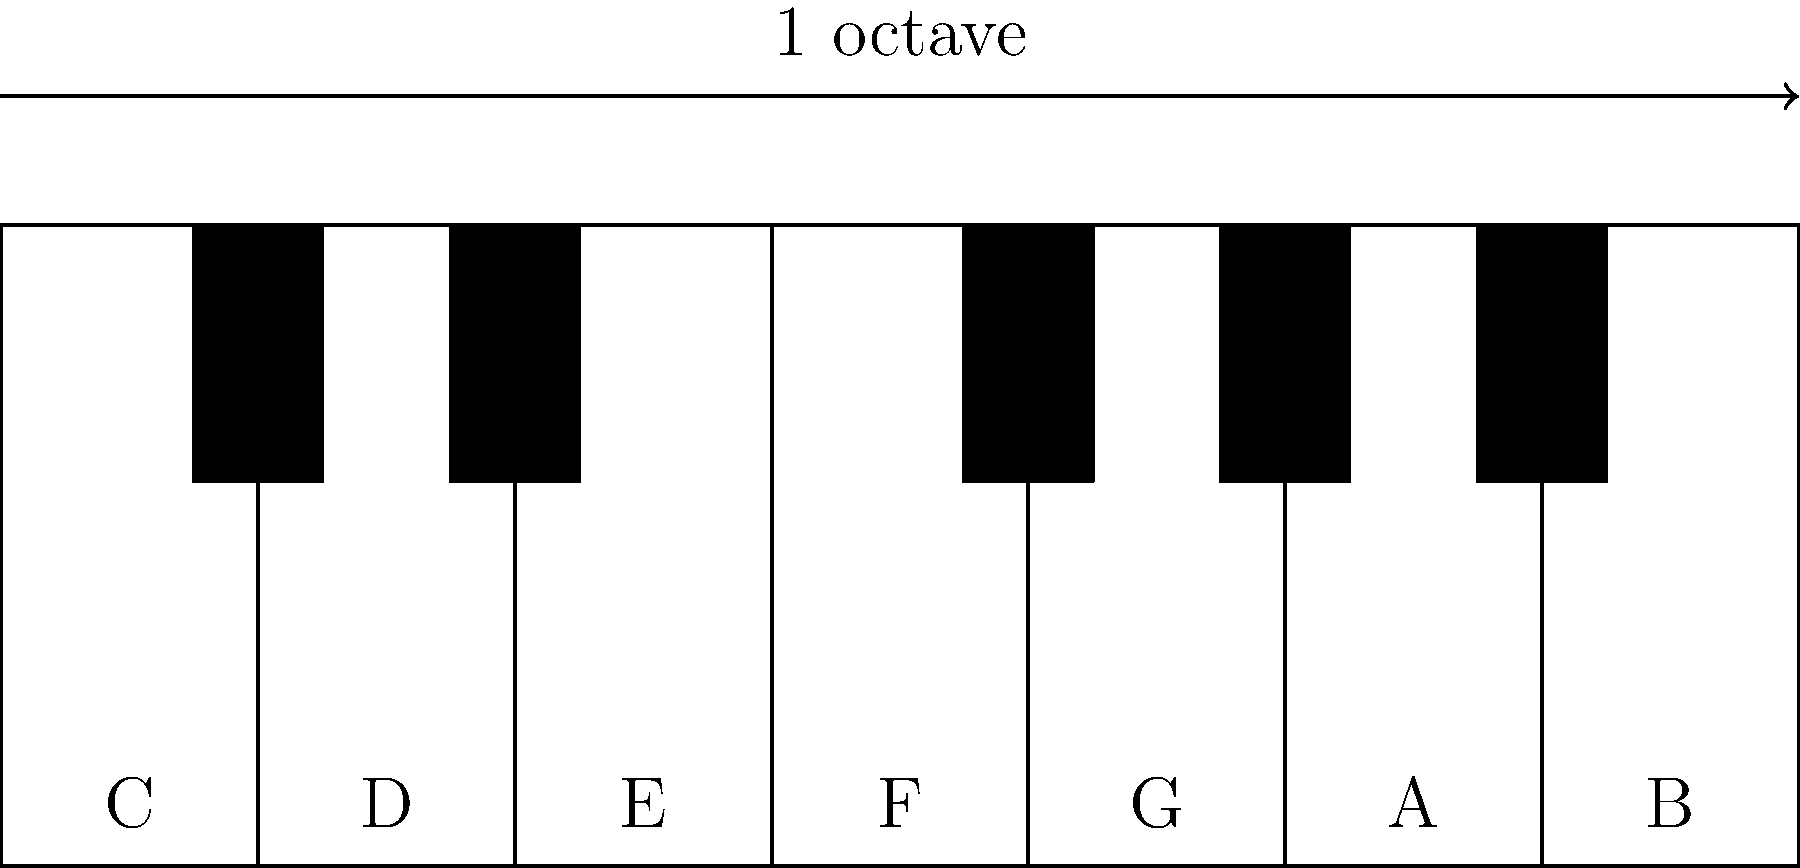As a violinist, you understand the importance of musical intervals. Looking at the piano keyboard diagram, what is the frequency ratio between the note C and the note G (perfect fifth interval)? To find the frequency ratio of a perfect fifth (C to G), we can follow these steps:

1. Recall that an octave has a frequency ratio of 2:1.

2. On a piano, there are 12 semitones in an octave.

3. The interval from C to G is 7 semitones.

4. To calculate the ratio, we can use the formula:
   $$ \text{Ratio} = 2^{\frac{\text{semitones}}{12}} $$

5. Substituting our values:
   $$ \text{Ratio} = 2^{\frac{7}{12}} $$

6. Calculate:
   $$ \text{Ratio} \approx 1.4983 $$

7. This can be approximated as a 3:2 ratio.

In musical theory, this 3:2 ratio is significant as it forms the basis of the perfect fifth, a fundamental interval in Western music and particularly important in string instruments like the violin.
Answer: $3:2$ or $1.5:1$ 